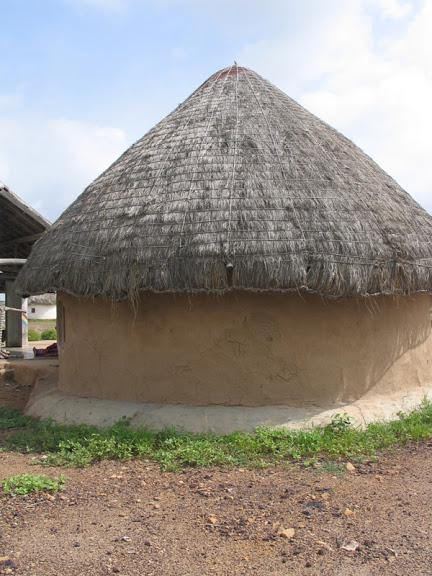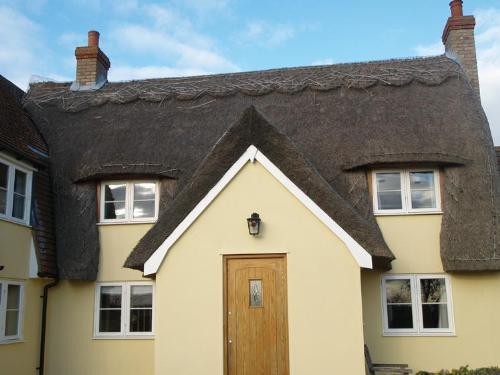The first image is the image on the left, the second image is the image on the right. Evaluate the accuracy of this statement regarding the images: "The thatching on the house in the image to the right, is a dark gray.". Is it true? Answer yes or no. Yes. The first image is the image on the left, the second image is the image on the right. Analyze the images presented: Is the assertion "The right image shows the front of a pale stucco-look house with a scalloped border on the peak of the roof and with two notches in the roof's bottom edge to accommodate windows." valid? Answer yes or no. Yes. 